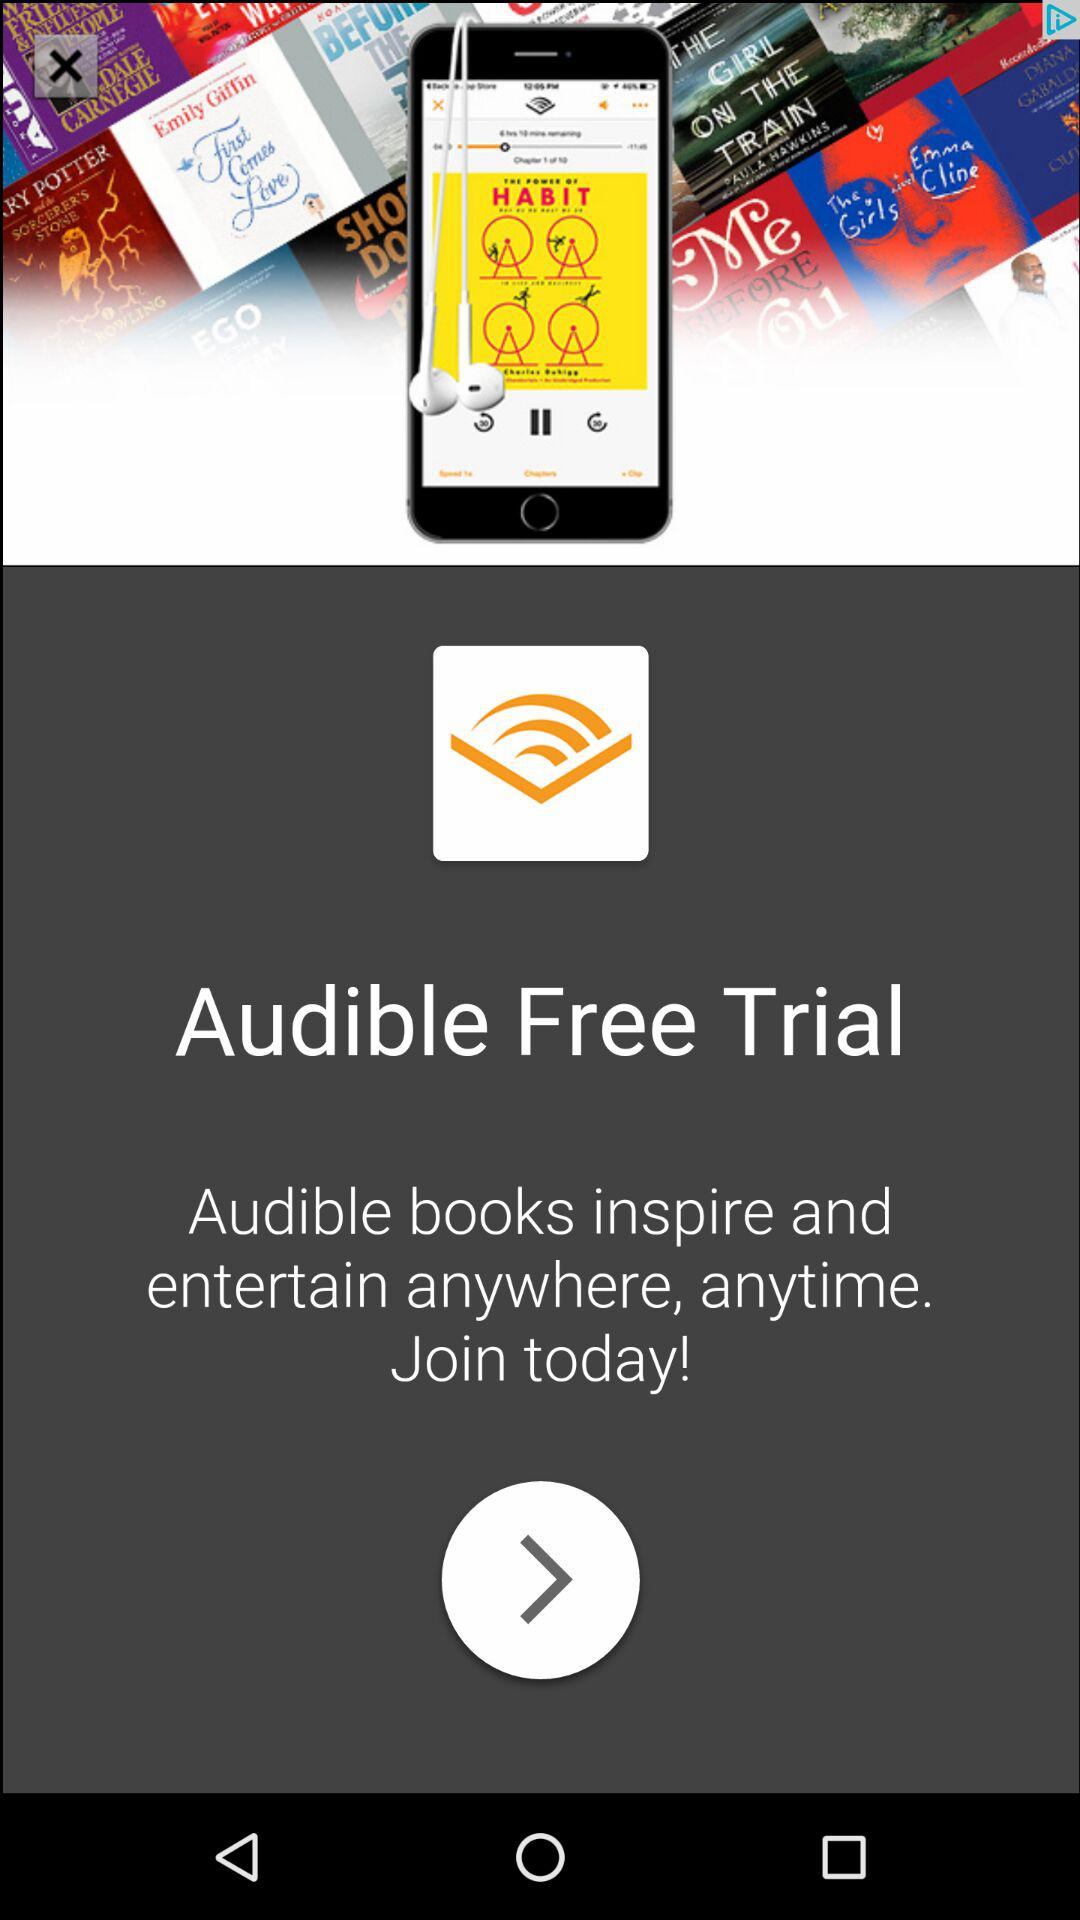What is the app name? The app name is "Audible". 